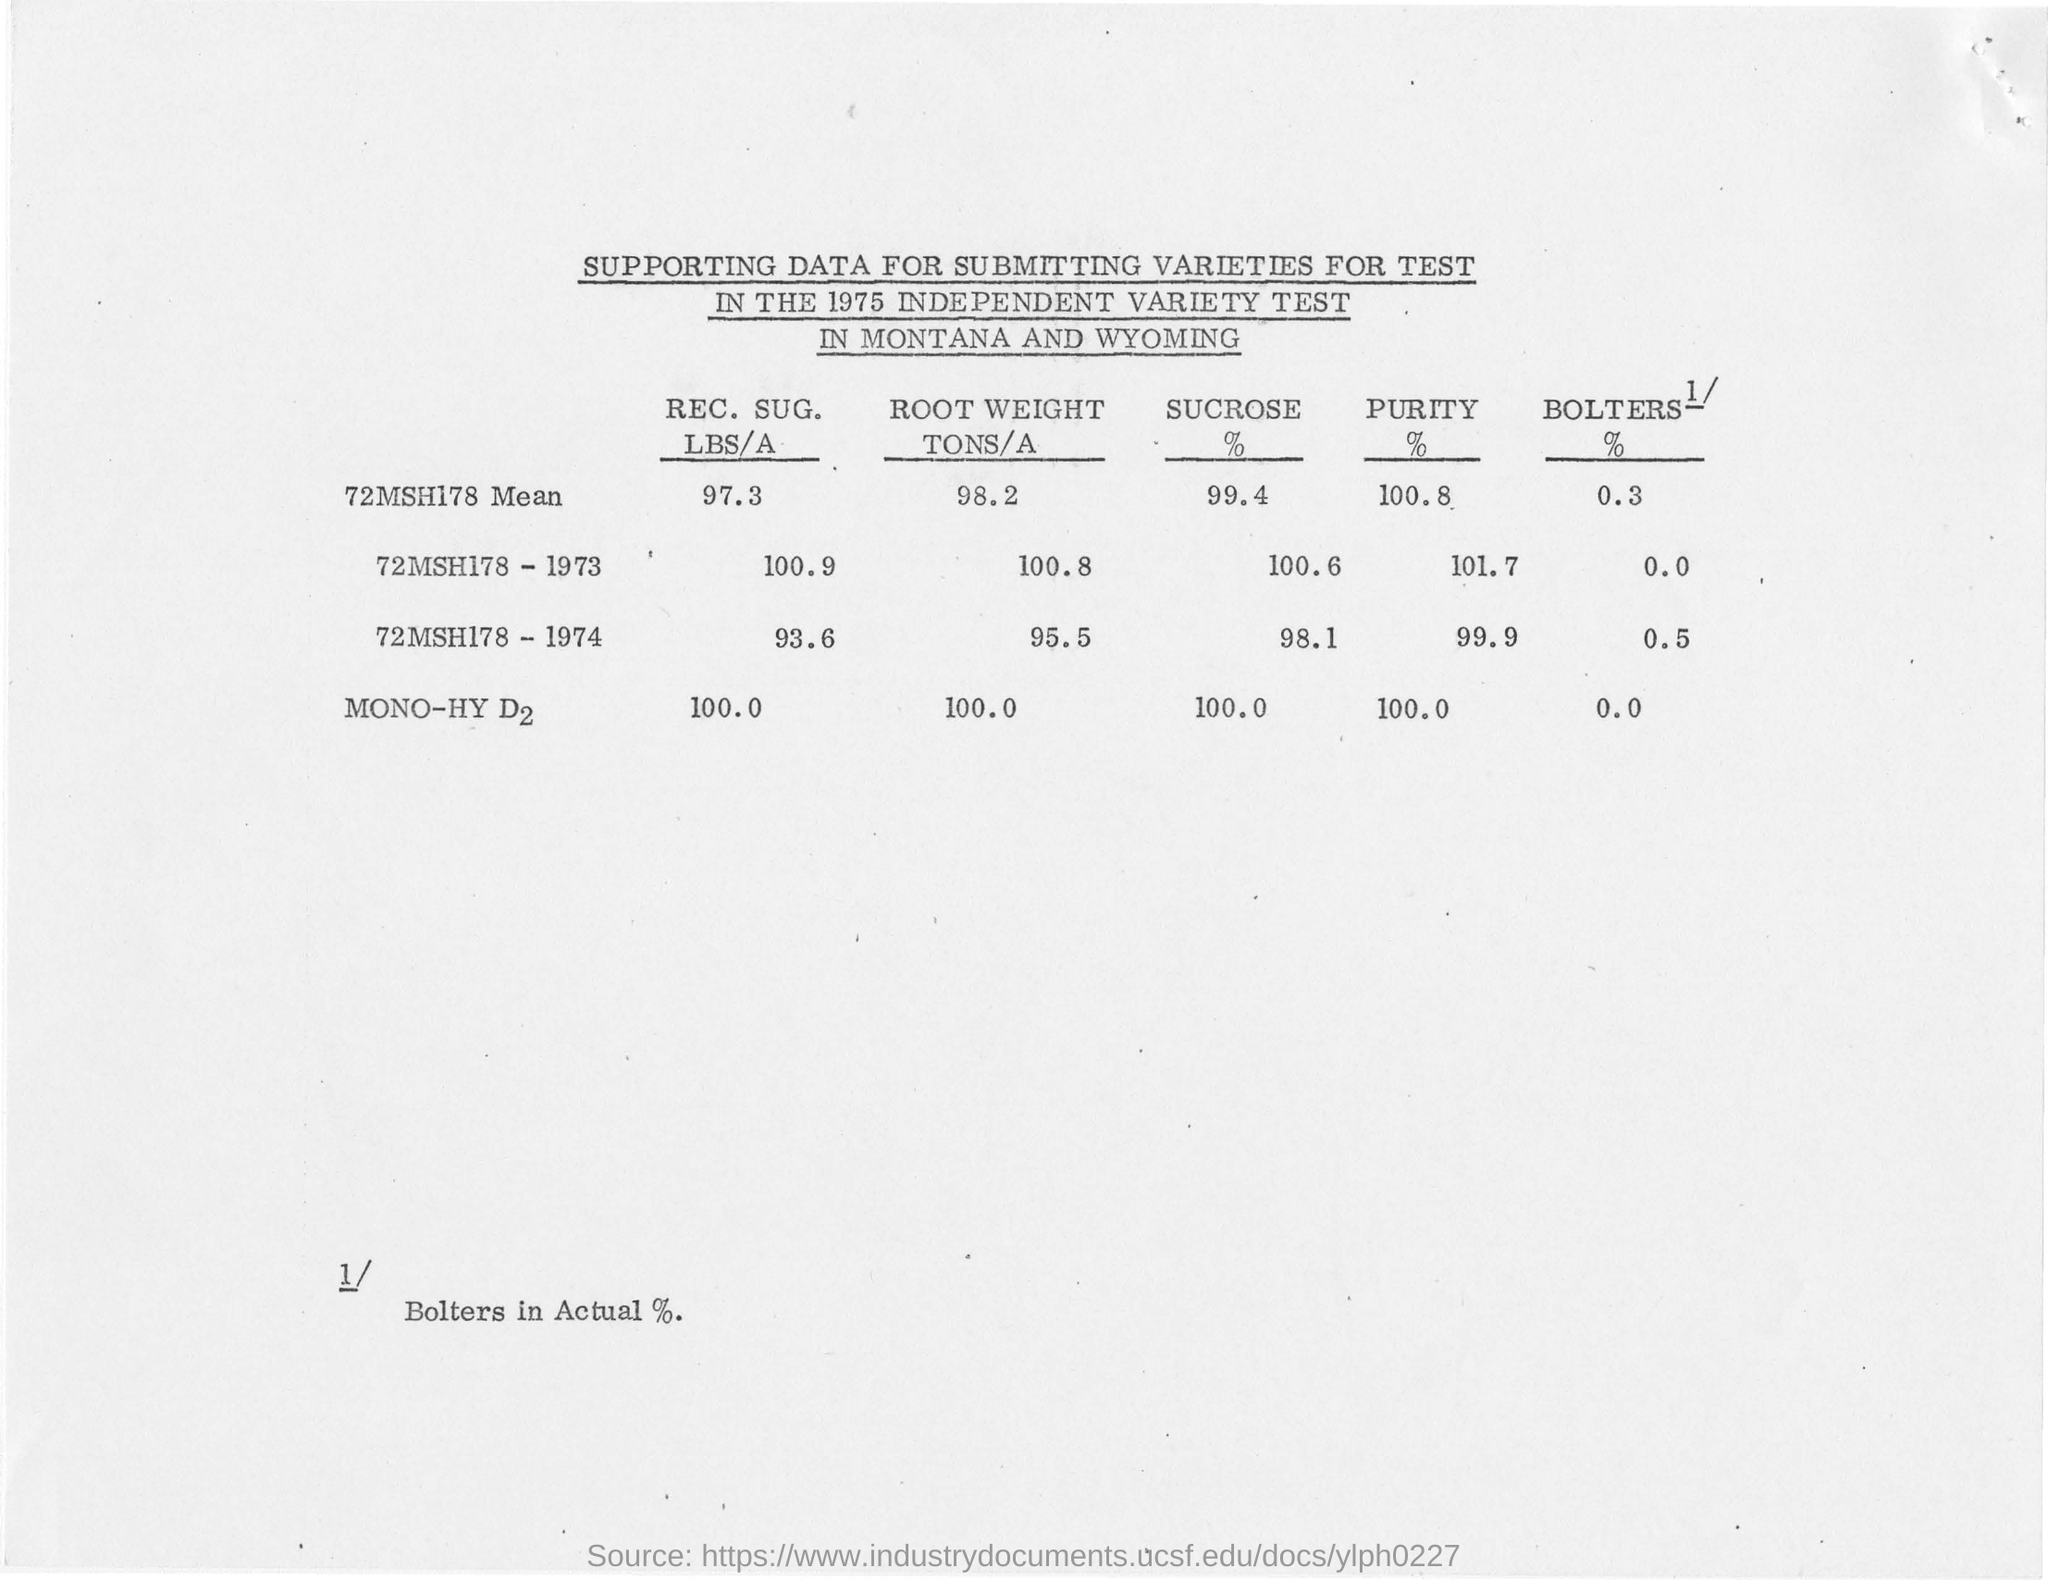Which year was the test conducted?
Your response must be concise. 1975. Where was the test conducted?
Offer a very short reply. IN MONTANA AND WYOMING. What is the SUCROSE % of 72MSH178 Mean?
Provide a short and direct response. 99.4%. What is the PURITY % of MONO-HY D2?
Your response must be concise. 100. 